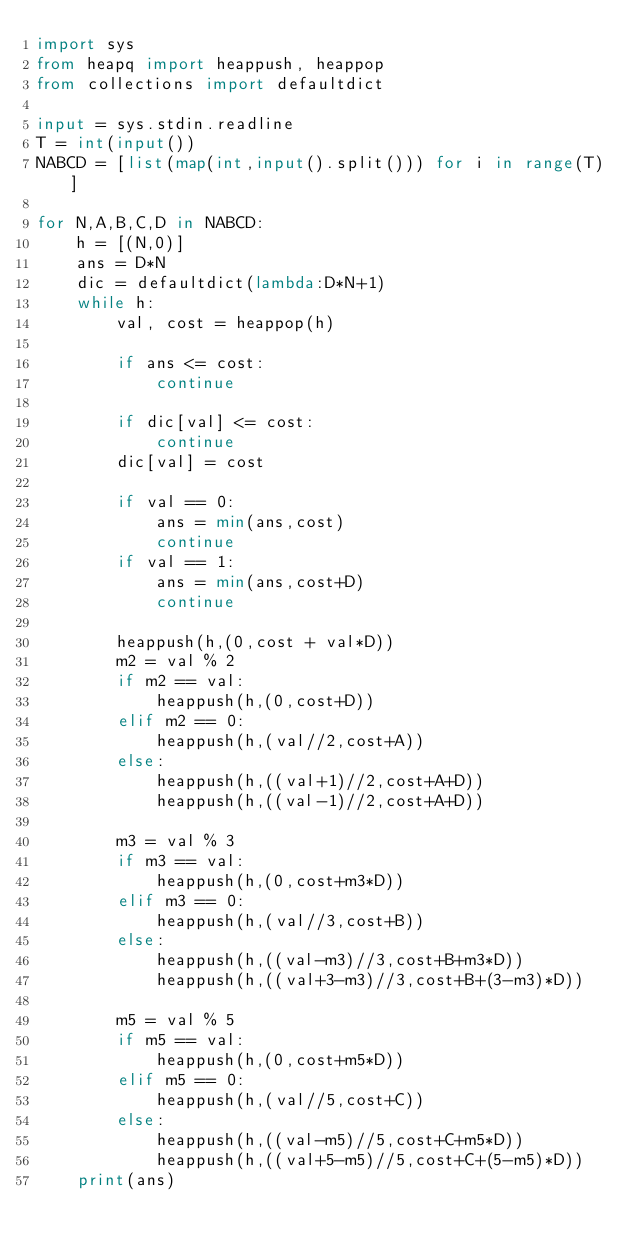<code> <loc_0><loc_0><loc_500><loc_500><_Python_>import sys
from heapq import heappush, heappop
from collections import defaultdict

input = sys.stdin.readline
T = int(input())
NABCD = [list(map(int,input().split())) for i in range(T)]

for N,A,B,C,D in NABCD:
    h = [(N,0)]
    ans = D*N
    dic = defaultdict(lambda:D*N+1)
    while h:
        val, cost = heappop(h)

        if ans <= cost:
            continue

        if dic[val] <= cost:
            continue
        dic[val] = cost

        if val == 0:
            ans = min(ans,cost)
            continue
        if val == 1:
            ans = min(ans,cost+D)
            continue

        heappush(h,(0,cost + val*D))
        m2 = val % 2
        if m2 == val:
            heappush(h,(0,cost+D))
        elif m2 == 0:
            heappush(h,(val//2,cost+A))
        else:
            heappush(h,((val+1)//2,cost+A+D))
            heappush(h,((val-1)//2,cost+A+D))
        
        m3 = val % 3
        if m3 == val:
            heappush(h,(0,cost+m3*D))
        elif m3 == 0:
            heappush(h,(val//3,cost+B))
        else:
            heappush(h,((val-m3)//3,cost+B+m3*D))
            heappush(h,((val+3-m3)//3,cost+B+(3-m3)*D))

        m5 = val % 5
        if m5 == val:
            heappush(h,(0,cost+m5*D))
        elif m5 == 0:
            heappush(h,(val//5,cost+C))
        else:
            heappush(h,((val-m5)//5,cost+C+m5*D))
            heappush(h,((val+5-m5)//5,cost+C+(5-m5)*D))
    print(ans)



</code> 